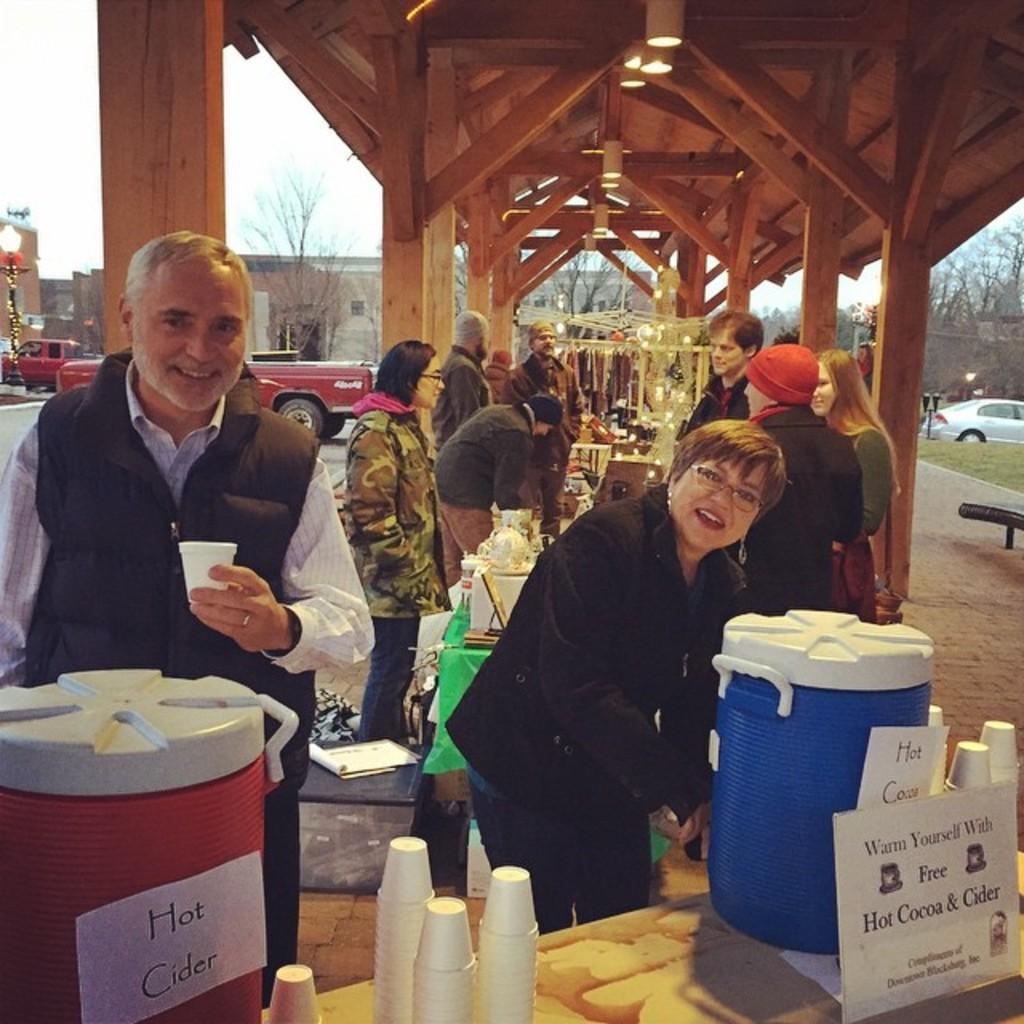Can you describe this image briefly? In this picture there are group of people those who are purchasing the ornaments at the center of the image and some are standing near water point, there are some glasses which are placed on the table at the center of the image and there are lumps above the area of the image, there are trees around there area of the image and buildings, there are cars around the area, it seems to be a market place. 